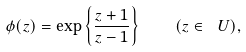<formula> <loc_0><loc_0><loc_500><loc_500>\phi ( z ) = \exp \left \{ \frac { z + 1 } { z - 1 } \right \} \quad ( z \in \ U ) ,</formula> 